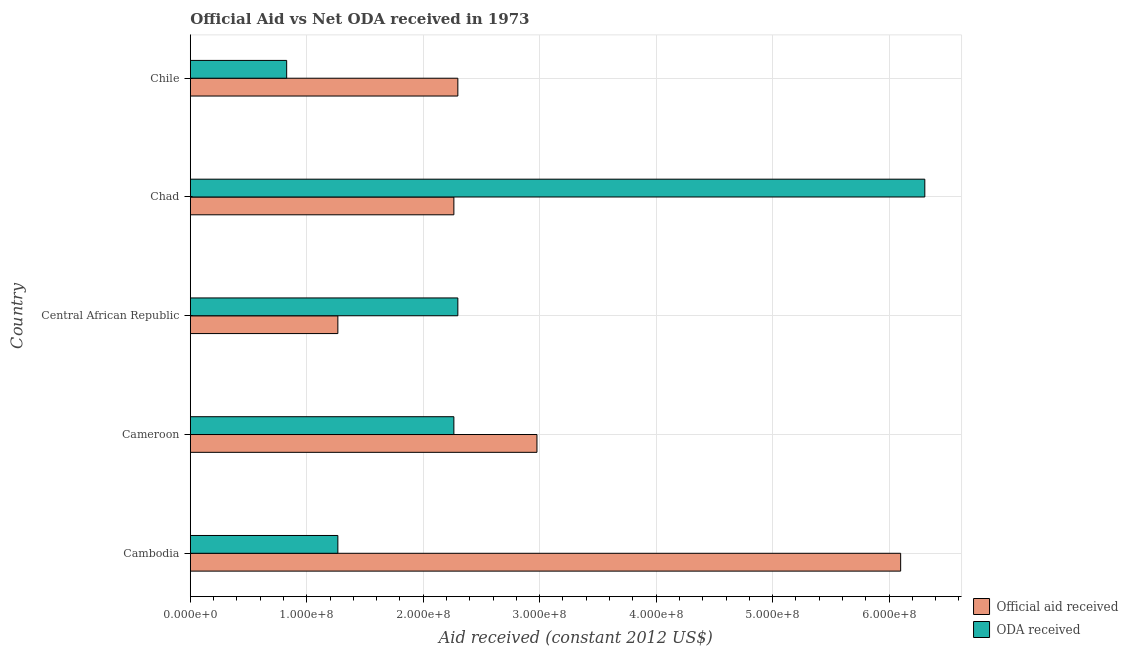How many different coloured bars are there?
Offer a very short reply. 2. Are the number of bars per tick equal to the number of legend labels?
Give a very brief answer. Yes. How many bars are there on the 2nd tick from the top?
Offer a very short reply. 2. What is the oda received in Cameroon?
Your answer should be very brief. 2.26e+08. Across all countries, what is the maximum oda received?
Offer a very short reply. 6.31e+08. Across all countries, what is the minimum official aid received?
Make the answer very short. 1.27e+08. In which country was the oda received maximum?
Make the answer very short. Chad. In which country was the oda received minimum?
Ensure brevity in your answer.  Chile. What is the total oda received in the graph?
Your answer should be compact. 1.30e+09. What is the difference between the oda received in Cambodia and that in Cameroon?
Ensure brevity in your answer.  -9.96e+07. What is the difference between the official aid received in Chad and the oda received in Chile?
Make the answer very short. 1.44e+08. What is the average oda received per country?
Your answer should be compact. 2.59e+08. What is the difference between the oda received and official aid received in Chad?
Offer a very short reply. 4.04e+08. In how many countries, is the oda received greater than 480000000 US$?
Your answer should be very brief. 1. What is the ratio of the oda received in Cameroon to that in Central African Republic?
Make the answer very short. 0.98. Is the oda received in Chad less than that in Chile?
Offer a terse response. No. Is the difference between the oda received in Cameroon and Chad greater than the difference between the official aid received in Cameroon and Chad?
Your answer should be compact. No. What is the difference between the highest and the second highest official aid received?
Provide a succinct answer. 3.12e+08. What is the difference between the highest and the lowest official aid received?
Your answer should be very brief. 4.83e+08. In how many countries, is the official aid received greater than the average official aid received taken over all countries?
Your answer should be compact. 1. Is the sum of the oda received in Cameroon and Chad greater than the maximum official aid received across all countries?
Your answer should be very brief. Yes. What does the 2nd bar from the top in Cambodia represents?
Your response must be concise. Official aid received. What does the 1st bar from the bottom in Cameroon represents?
Your answer should be compact. Official aid received. Are all the bars in the graph horizontal?
Keep it short and to the point. Yes. How many countries are there in the graph?
Keep it short and to the point. 5. What is the difference between two consecutive major ticks on the X-axis?
Your answer should be very brief. 1.00e+08. Are the values on the major ticks of X-axis written in scientific E-notation?
Provide a short and direct response. Yes. Does the graph contain grids?
Keep it short and to the point. Yes. How are the legend labels stacked?
Give a very brief answer. Vertical. What is the title of the graph?
Ensure brevity in your answer.  Official Aid vs Net ODA received in 1973 . What is the label or title of the X-axis?
Your answer should be compact. Aid received (constant 2012 US$). What is the label or title of the Y-axis?
Offer a very short reply. Country. What is the Aid received (constant 2012 US$) in Official aid received in Cambodia?
Your answer should be compact. 6.10e+08. What is the Aid received (constant 2012 US$) of ODA received in Cambodia?
Offer a terse response. 1.27e+08. What is the Aid received (constant 2012 US$) of Official aid received in Cameroon?
Your answer should be very brief. 2.98e+08. What is the Aid received (constant 2012 US$) of ODA received in Cameroon?
Provide a succinct answer. 2.26e+08. What is the Aid received (constant 2012 US$) of Official aid received in Central African Republic?
Provide a short and direct response. 1.27e+08. What is the Aid received (constant 2012 US$) of ODA received in Central African Republic?
Keep it short and to the point. 2.30e+08. What is the Aid received (constant 2012 US$) of Official aid received in Chad?
Offer a very short reply. 2.26e+08. What is the Aid received (constant 2012 US$) of ODA received in Chad?
Ensure brevity in your answer.  6.31e+08. What is the Aid received (constant 2012 US$) in Official aid received in Chile?
Your answer should be compact. 2.30e+08. What is the Aid received (constant 2012 US$) in ODA received in Chile?
Provide a succinct answer. 8.28e+07. Across all countries, what is the maximum Aid received (constant 2012 US$) of Official aid received?
Ensure brevity in your answer.  6.10e+08. Across all countries, what is the maximum Aid received (constant 2012 US$) of ODA received?
Your answer should be compact. 6.31e+08. Across all countries, what is the minimum Aid received (constant 2012 US$) of Official aid received?
Make the answer very short. 1.27e+08. Across all countries, what is the minimum Aid received (constant 2012 US$) of ODA received?
Offer a terse response. 8.28e+07. What is the total Aid received (constant 2012 US$) in Official aid received in the graph?
Give a very brief answer. 1.49e+09. What is the total Aid received (constant 2012 US$) of ODA received in the graph?
Keep it short and to the point. 1.30e+09. What is the difference between the Aid received (constant 2012 US$) in Official aid received in Cambodia and that in Cameroon?
Provide a succinct answer. 3.12e+08. What is the difference between the Aid received (constant 2012 US$) in ODA received in Cambodia and that in Cameroon?
Your answer should be very brief. -9.96e+07. What is the difference between the Aid received (constant 2012 US$) of Official aid received in Cambodia and that in Central African Republic?
Your answer should be compact. 4.83e+08. What is the difference between the Aid received (constant 2012 US$) in ODA received in Cambodia and that in Central African Republic?
Offer a very short reply. -1.03e+08. What is the difference between the Aid received (constant 2012 US$) of Official aid received in Cambodia and that in Chad?
Your response must be concise. 3.84e+08. What is the difference between the Aid received (constant 2012 US$) of ODA received in Cambodia and that in Chad?
Your answer should be very brief. -5.04e+08. What is the difference between the Aid received (constant 2012 US$) in Official aid received in Cambodia and that in Chile?
Ensure brevity in your answer.  3.80e+08. What is the difference between the Aid received (constant 2012 US$) of ODA received in Cambodia and that in Chile?
Offer a very short reply. 4.40e+07. What is the difference between the Aid received (constant 2012 US$) of Official aid received in Cameroon and that in Central African Republic?
Your response must be concise. 1.71e+08. What is the difference between the Aid received (constant 2012 US$) of ODA received in Cameroon and that in Central African Republic?
Make the answer very short. -3.41e+06. What is the difference between the Aid received (constant 2012 US$) in Official aid received in Cameroon and that in Chad?
Your response must be concise. 7.13e+07. What is the difference between the Aid received (constant 2012 US$) in ODA received in Cameroon and that in Chad?
Your response must be concise. -4.04e+08. What is the difference between the Aid received (constant 2012 US$) in Official aid received in Cameroon and that in Chile?
Keep it short and to the point. 6.79e+07. What is the difference between the Aid received (constant 2012 US$) in ODA received in Cameroon and that in Chile?
Provide a short and direct response. 1.44e+08. What is the difference between the Aid received (constant 2012 US$) in Official aid received in Central African Republic and that in Chad?
Provide a succinct answer. -9.96e+07. What is the difference between the Aid received (constant 2012 US$) in ODA received in Central African Republic and that in Chad?
Make the answer very short. -4.01e+08. What is the difference between the Aid received (constant 2012 US$) in Official aid received in Central African Republic and that in Chile?
Keep it short and to the point. -1.03e+08. What is the difference between the Aid received (constant 2012 US$) of ODA received in Central African Republic and that in Chile?
Your answer should be very brief. 1.47e+08. What is the difference between the Aid received (constant 2012 US$) of Official aid received in Chad and that in Chile?
Your answer should be compact. -3.41e+06. What is the difference between the Aid received (constant 2012 US$) in ODA received in Chad and that in Chile?
Offer a terse response. 5.48e+08. What is the difference between the Aid received (constant 2012 US$) of Official aid received in Cambodia and the Aid received (constant 2012 US$) of ODA received in Cameroon?
Make the answer very short. 3.84e+08. What is the difference between the Aid received (constant 2012 US$) of Official aid received in Cambodia and the Aid received (constant 2012 US$) of ODA received in Central African Republic?
Offer a terse response. 3.80e+08. What is the difference between the Aid received (constant 2012 US$) in Official aid received in Cambodia and the Aid received (constant 2012 US$) in ODA received in Chad?
Provide a succinct answer. -2.07e+07. What is the difference between the Aid received (constant 2012 US$) in Official aid received in Cambodia and the Aid received (constant 2012 US$) in ODA received in Chile?
Ensure brevity in your answer.  5.27e+08. What is the difference between the Aid received (constant 2012 US$) in Official aid received in Cameroon and the Aid received (constant 2012 US$) in ODA received in Central African Republic?
Provide a short and direct response. 6.79e+07. What is the difference between the Aid received (constant 2012 US$) in Official aid received in Cameroon and the Aid received (constant 2012 US$) in ODA received in Chad?
Ensure brevity in your answer.  -3.33e+08. What is the difference between the Aid received (constant 2012 US$) in Official aid received in Cameroon and the Aid received (constant 2012 US$) in ODA received in Chile?
Keep it short and to the point. 2.15e+08. What is the difference between the Aid received (constant 2012 US$) in Official aid received in Central African Republic and the Aid received (constant 2012 US$) in ODA received in Chad?
Make the answer very short. -5.04e+08. What is the difference between the Aid received (constant 2012 US$) of Official aid received in Central African Republic and the Aid received (constant 2012 US$) of ODA received in Chile?
Your answer should be compact. 4.40e+07. What is the difference between the Aid received (constant 2012 US$) in Official aid received in Chad and the Aid received (constant 2012 US$) in ODA received in Chile?
Your answer should be compact. 1.44e+08. What is the average Aid received (constant 2012 US$) of Official aid received per country?
Your answer should be compact. 2.98e+08. What is the average Aid received (constant 2012 US$) in ODA received per country?
Make the answer very short. 2.59e+08. What is the difference between the Aid received (constant 2012 US$) of Official aid received and Aid received (constant 2012 US$) of ODA received in Cambodia?
Offer a very short reply. 4.83e+08. What is the difference between the Aid received (constant 2012 US$) in Official aid received and Aid received (constant 2012 US$) in ODA received in Cameroon?
Your response must be concise. 7.13e+07. What is the difference between the Aid received (constant 2012 US$) of Official aid received and Aid received (constant 2012 US$) of ODA received in Central African Republic?
Your answer should be very brief. -1.03e+08. What is the difference between the Aid received (constant 2012 US$) of Official aid received and Aid received (constant 2012 US$) of ODA received in Chad?
Your answer should be very brief. -4.04e+08. What is the difference between the Aid received (constant 2012 US$) of Official aid received and Aid received (constant 2012 US$) of ODA received in Chile?
Make the answer very short. 1.47e+08. What is the ratio of the Aid received (constant 2012 US$) of Official aid received in Cambodia to that in Cameroon?
Ensure brevity in your answer.  2.05. What is the ratio of the Aid received (constant 2012 US$) in ODA received in Cambodia to that in Cameroon?
Make the answer very short. 0.56. What is the ratio of the Aid received (constant 2012 US$) of Official aid received in Cambodia to that in Central African Republic?
Provide a succinct answer. 4.81. What is the ratio of the Aid received (constant 2012 US$) of ODA received in Cambodia to that in Central African Republic?
Give a very brief answer. 0.55. What is the ratio of the Aid received (constant 2012 US$) in Official aid received in Cambodia to that in Chad?
Offer a terse response. 2.69. What is the ratio of the Aid received (constant 2012 US$) of ODA received in Cambodia to that in Chad?
Ensure brevity in your answer.  0.2. What is the ratio of the Aid received (constant 2012 US$) in Official aid received in Cambodia to that in Chile?
Your answer should be compact. 2.65. What is the ratio of the Aid received (constant 2012 US$) of ODA received in Cambodia to that in Chile?
Provide a succinct answer. 1.53. What is the ratio of the Aid received (constant 2012 US$) of Official aid received in Cameroon to that in Central African Republic?
Give a very brief answer. 2.35. What is the ratio of the Aid received (constant 2012 US$) in ODA received in Cameroon to that in Central African Republic?
Provide a short and direct response. 0.99. What is the ratio of the Aid received (constant 2012 US$) in Official aid received in Cameroon to that in Chad?
Offer a terse response. 1.32. What is the ratio of the Aid received (constant 2012 US$) of ODA received in Cameroon to that in Chad?
Your answer should be compact. 0.36. What is the ratio of the Aid received (constant 2012 US$) in Official aid received in Cameroon to that in Chile?
Your response must be concise. 1.3. What is the ratio of the Aid received (constant 2012 US$) of ODA received in Cameroon to that in Chile?
Your answer should be compact. 2.74. What is the ratio of the Aid received (constant 2012 US$) of Official aid received in Central African Republic to that in Chad?
Offer a very short reply. 0.56. What is the ratio of the Aid received (constant 2012 US$) of ODA received in Central African Republic to that in Chad?
Make the answer very short. 0.36. What is the ratio of the Aid received (constant 2012 US$) of Official aid received in Central African Republic to that in Chile?
Provide a short and direct response. 0.55. What is the ratio of the Aid received (constant 2012 US$) of ODA received in Central African Republic to that in Chile?
Give a very brief answer. 2.78. What is the ratio of the Aid received (constant 2012 US$) of Official aid received in Chad to that in Chile?
Offer a very short reply. 0.99. What is the ratio of the Aid received (constant 2012 US$) of ODA received in Chad to that in Chile?
Your answer should be compact. 7.62. What is the difference between the highest and the second highest Aid received (constant 2012 US$) of Official aid received?
Ensure brevity in your answer.  3.12e+08. What is the difference between the highest and the second highest Aid received (constant 2012 US$) of ODA received?
Your response must be concise. 4.01e+08. What is the difference between the highest and the lowest Aid received (constant 2012 US$) in Official aid received?
Offer a very short reply. 4.83e+08. What is the difference between the highest and the lowest Aid received (constant 2012 US$) in ODA received?
Make the answer very short. 5.48e+08. 